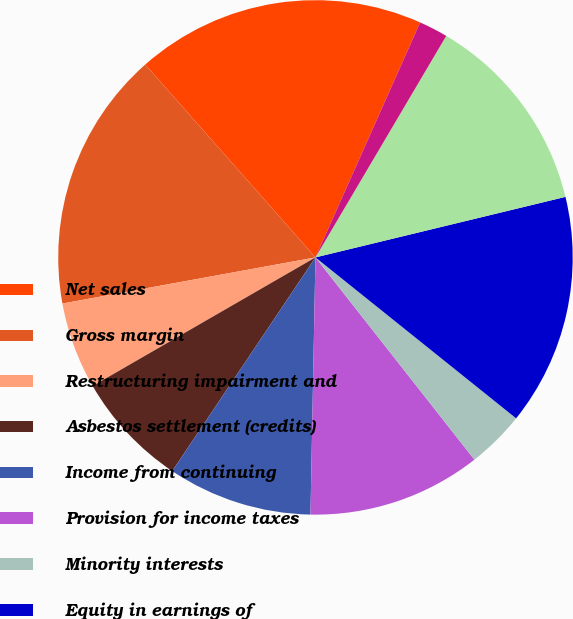Convert chart to OTSL. <chart><loc_0><loc_0><loc_500><loc_500><pie_chart><fcel>Net sales<fcel>Gross margin<fcel>Restructuring impairment and<fcel>Asbestos settlement (credits)<fcel>Income from continuing<fcel>Provision for income taxes<fcel>Minority interests<fcel>Equity in earnings of<fcel>Net income (loss)<fcel>Basic earnings (loss) per<nl><fcel>18.18%<fcel>16.36%<fcel>5.46%<fcel>7.27%<fcel>9.09%<fcel>10.91%<fcel>3.64%<fcel>14.54%<fcel>12.73%<fcel>1.82%<nl></chart> 